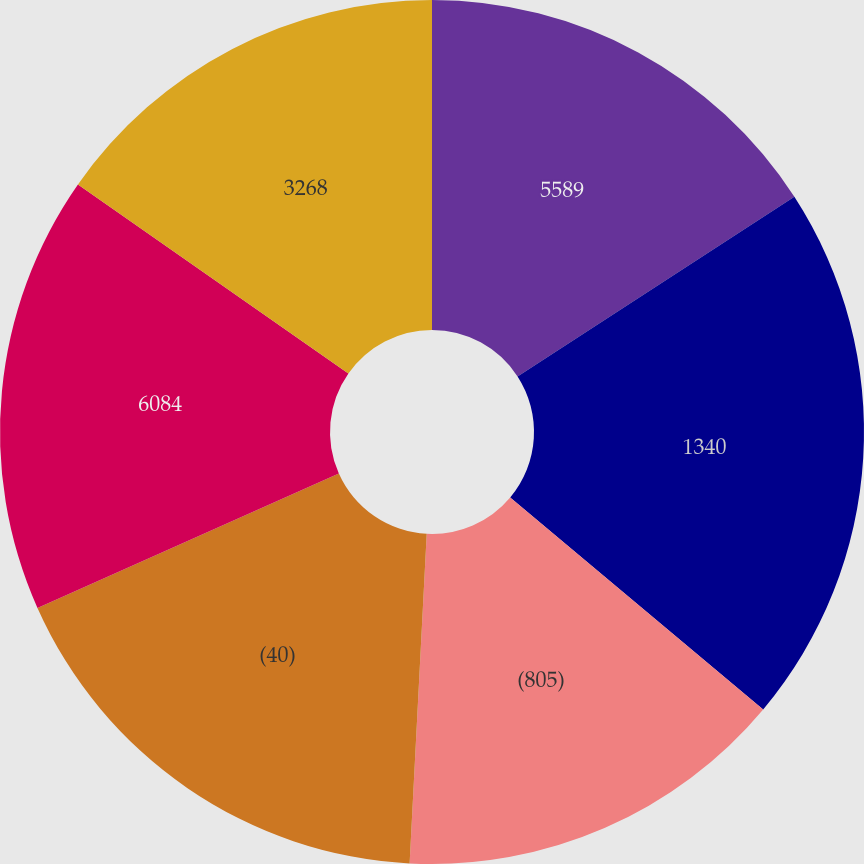Convert chart. <chart><loc_0><loc_0><loc_500><loc_500><pie_chart><fcel>5589<fcel>1340<fcel>(805)<fcel>(40)<fcel>6084<fcel>3268<nl><fcel>15.84%<fcel>20.26%<fcel>14.73%<fcel>17.5%<fcel>16.39%<fcel>15.29%<nl></chart> 